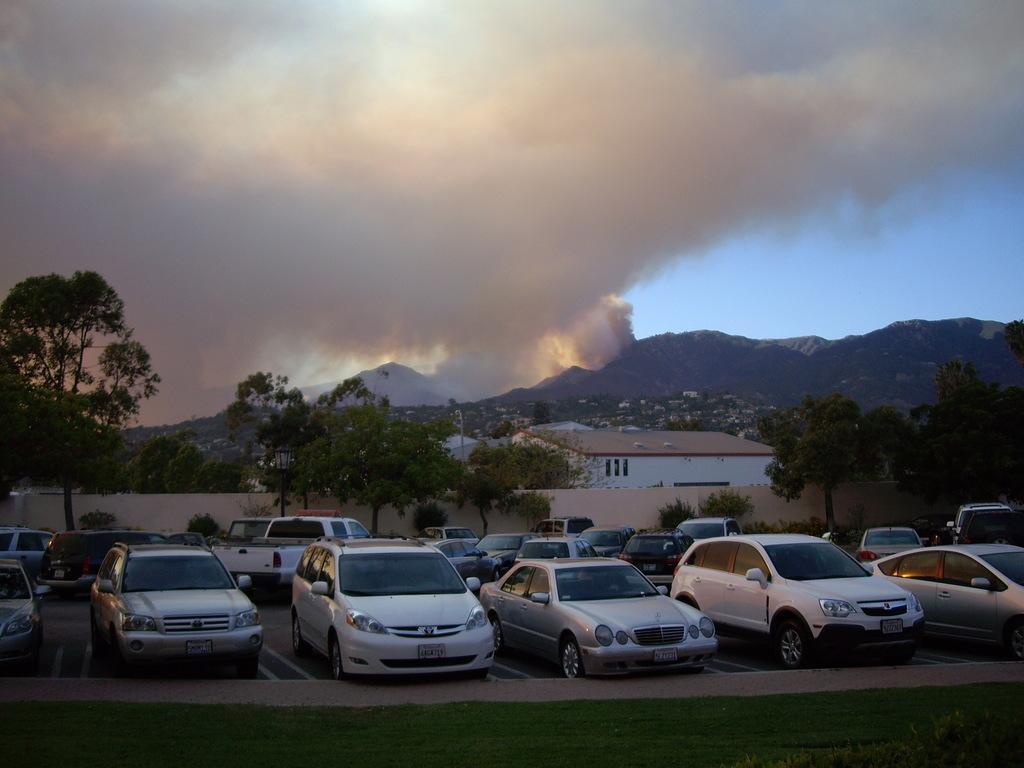In one or two sentences, can you explain what this image depicts? There are vehicles parked on the road. In front of them, there's grass on the ground. In the background, there are trees, buildings, a wall, there are mountains, there is smoke and there is blue sky. 